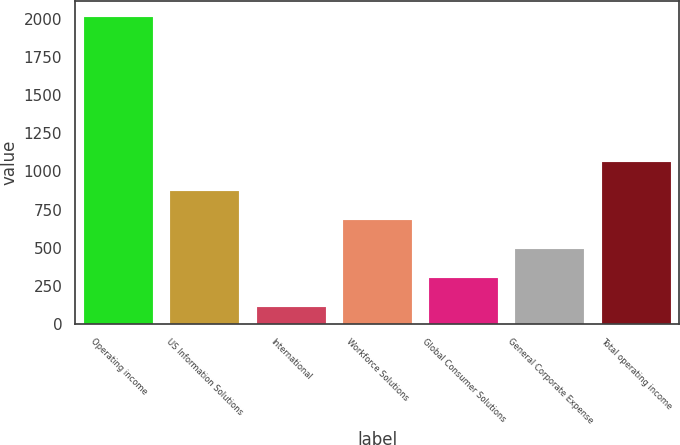<chart> <loc_0><loc_0><loc_500><loc_500><bar_chart><fcel>Operating income<fcel>US Information Solutions<fcel>International<fcel>Workforce Solutions<fcel>Global Consumer Solutions<fcel>General Corporate Expense<fcel>Total operating income<nl><fcel>2016<fcel>873.24<fcel>111.4<fcel>682.78<fcel>301.86<fcel>492.32<fcel>1063.7<nl></chart> 